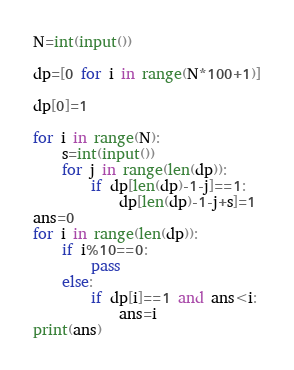Convert code to text. <code><loc_0><loc_0><loc_500><loc_500><_Python_>N=int(input())

dp=[0 for i in range(N*100+1)]

dp[0]=1

for i in range(N):
    s=int(input())
    for j in range(len(dp)):
        if dp[len(dp)-1-j]==1:
            dp[len(dp)-1-j+s]=1
ans=0
for i in range(len(dp)):
    if i%10==0:
        pass
    else:
        if dp[i]==1 and ans<i:
            ans=i
print(ans)</code> 